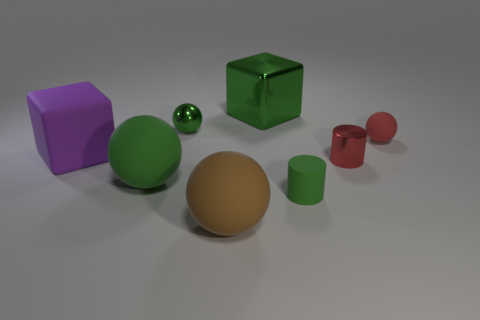Subtract all purple cylinders. How many green balls are left? 2 Subtract 1 balls. How many balls are left? 3 Add 2 large green matte spheres. How many objects exist? 10 Subtract all brown spheres. How many spheres are left? 3 Subtract all brown balls. How many balls are left? 3 Subtract all blue cylinders. Subtract all brown balls. How many cylinders are left? 2 Subtract all red spheres. Subtract all big brown rubber objects. How many objects are left? 6 Add 1 small red rubber balls. How many small red rubber balls are left? 2 Add 7 green matte objects. How many green matte objects exist? 9 Subtract 0 red cubes. How many objects are left? 8 